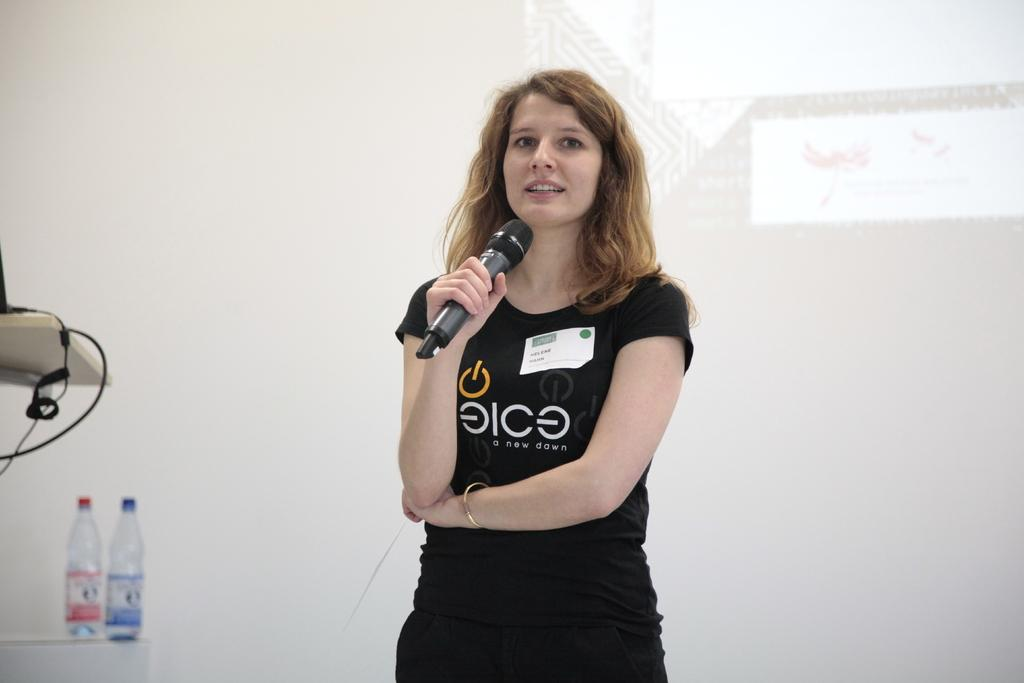Who is the main subject in the image? There is a woman in the image. What is the woman holding in the image? The woman is holding a microphone. What else can be seen in the image besides the woman? There are bottles in the image. What is visible in the background of the image? There is a wall in the background of the image. Is there a volcano erupting in the background of the image? No, there is no volcano present in the image. What type of kettle is being used by the woman in the image? There is no kettle visible in the image; the woman is holding a microphone. 